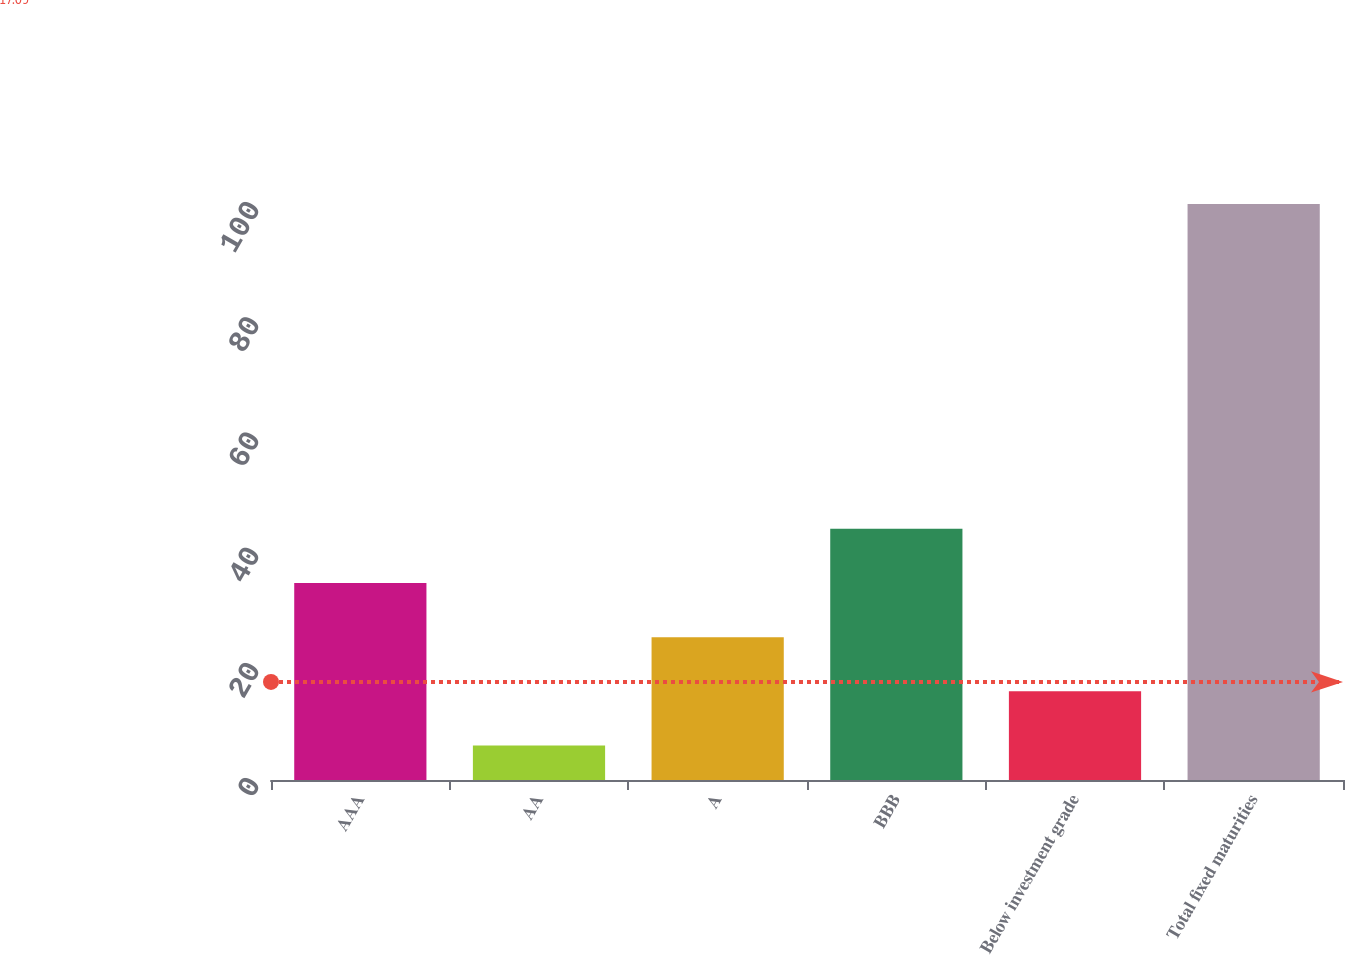Convert chart to OTSL. <chart><loc_0><loc_0><loc_500><loc_500><bar_chart><fcel>AAA<fcel>AA<fcel>A<fcel>BBB<fcel>Below investment grade<fcel>Total fixed maturities<nl><fcel>34.2<fcel>6<fcel>24.8<fcel>43.6<fcel>15.4<fcel>100<nl></chart> 